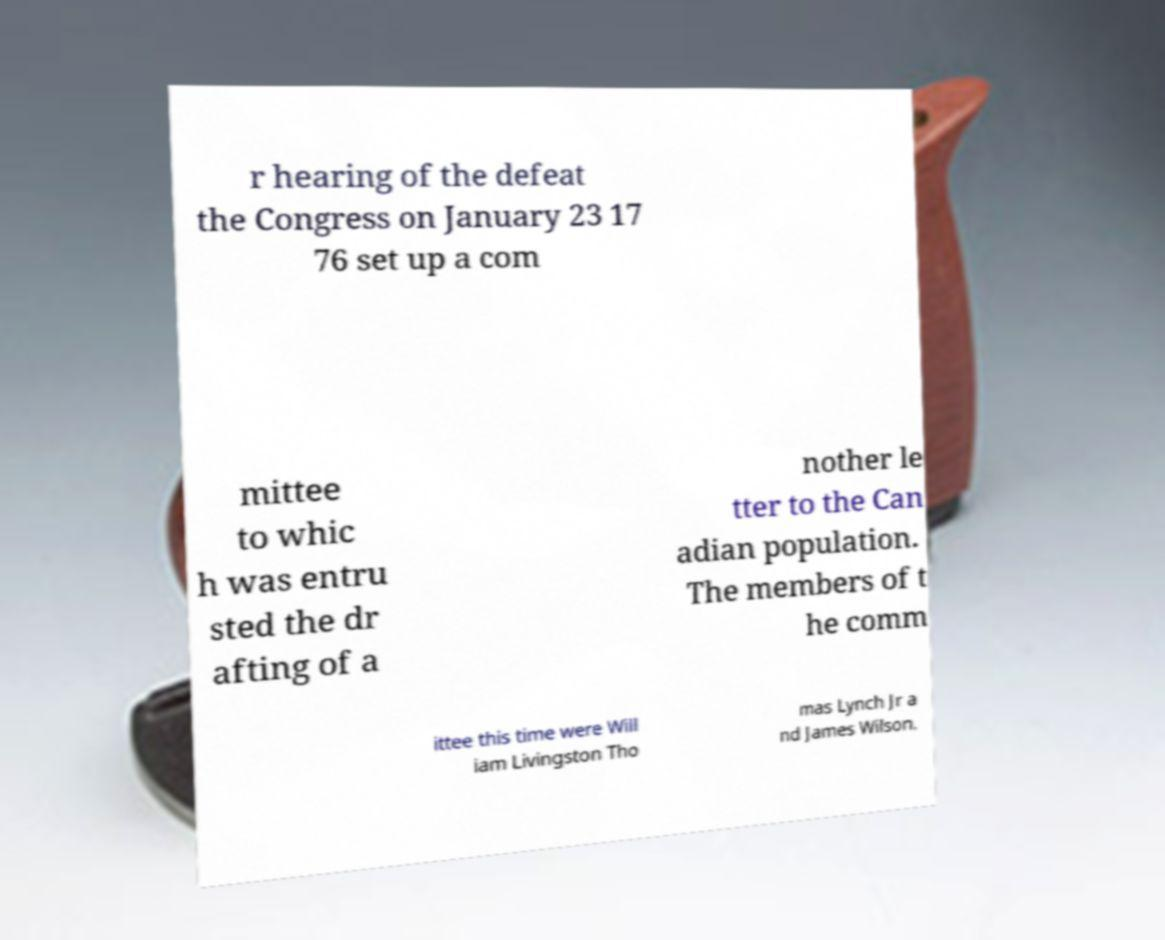Please identify and transcribe the text found in this image. r hearing of the defeat the Congress on January 23 17 76 set up a com mittee to whic h was entru sted the dr afting of a nother le tter to the Can adian population. The members of t he comm ittee this time were Will iam Livingston Tho mas Lynch Jr a nd James Wilson. 